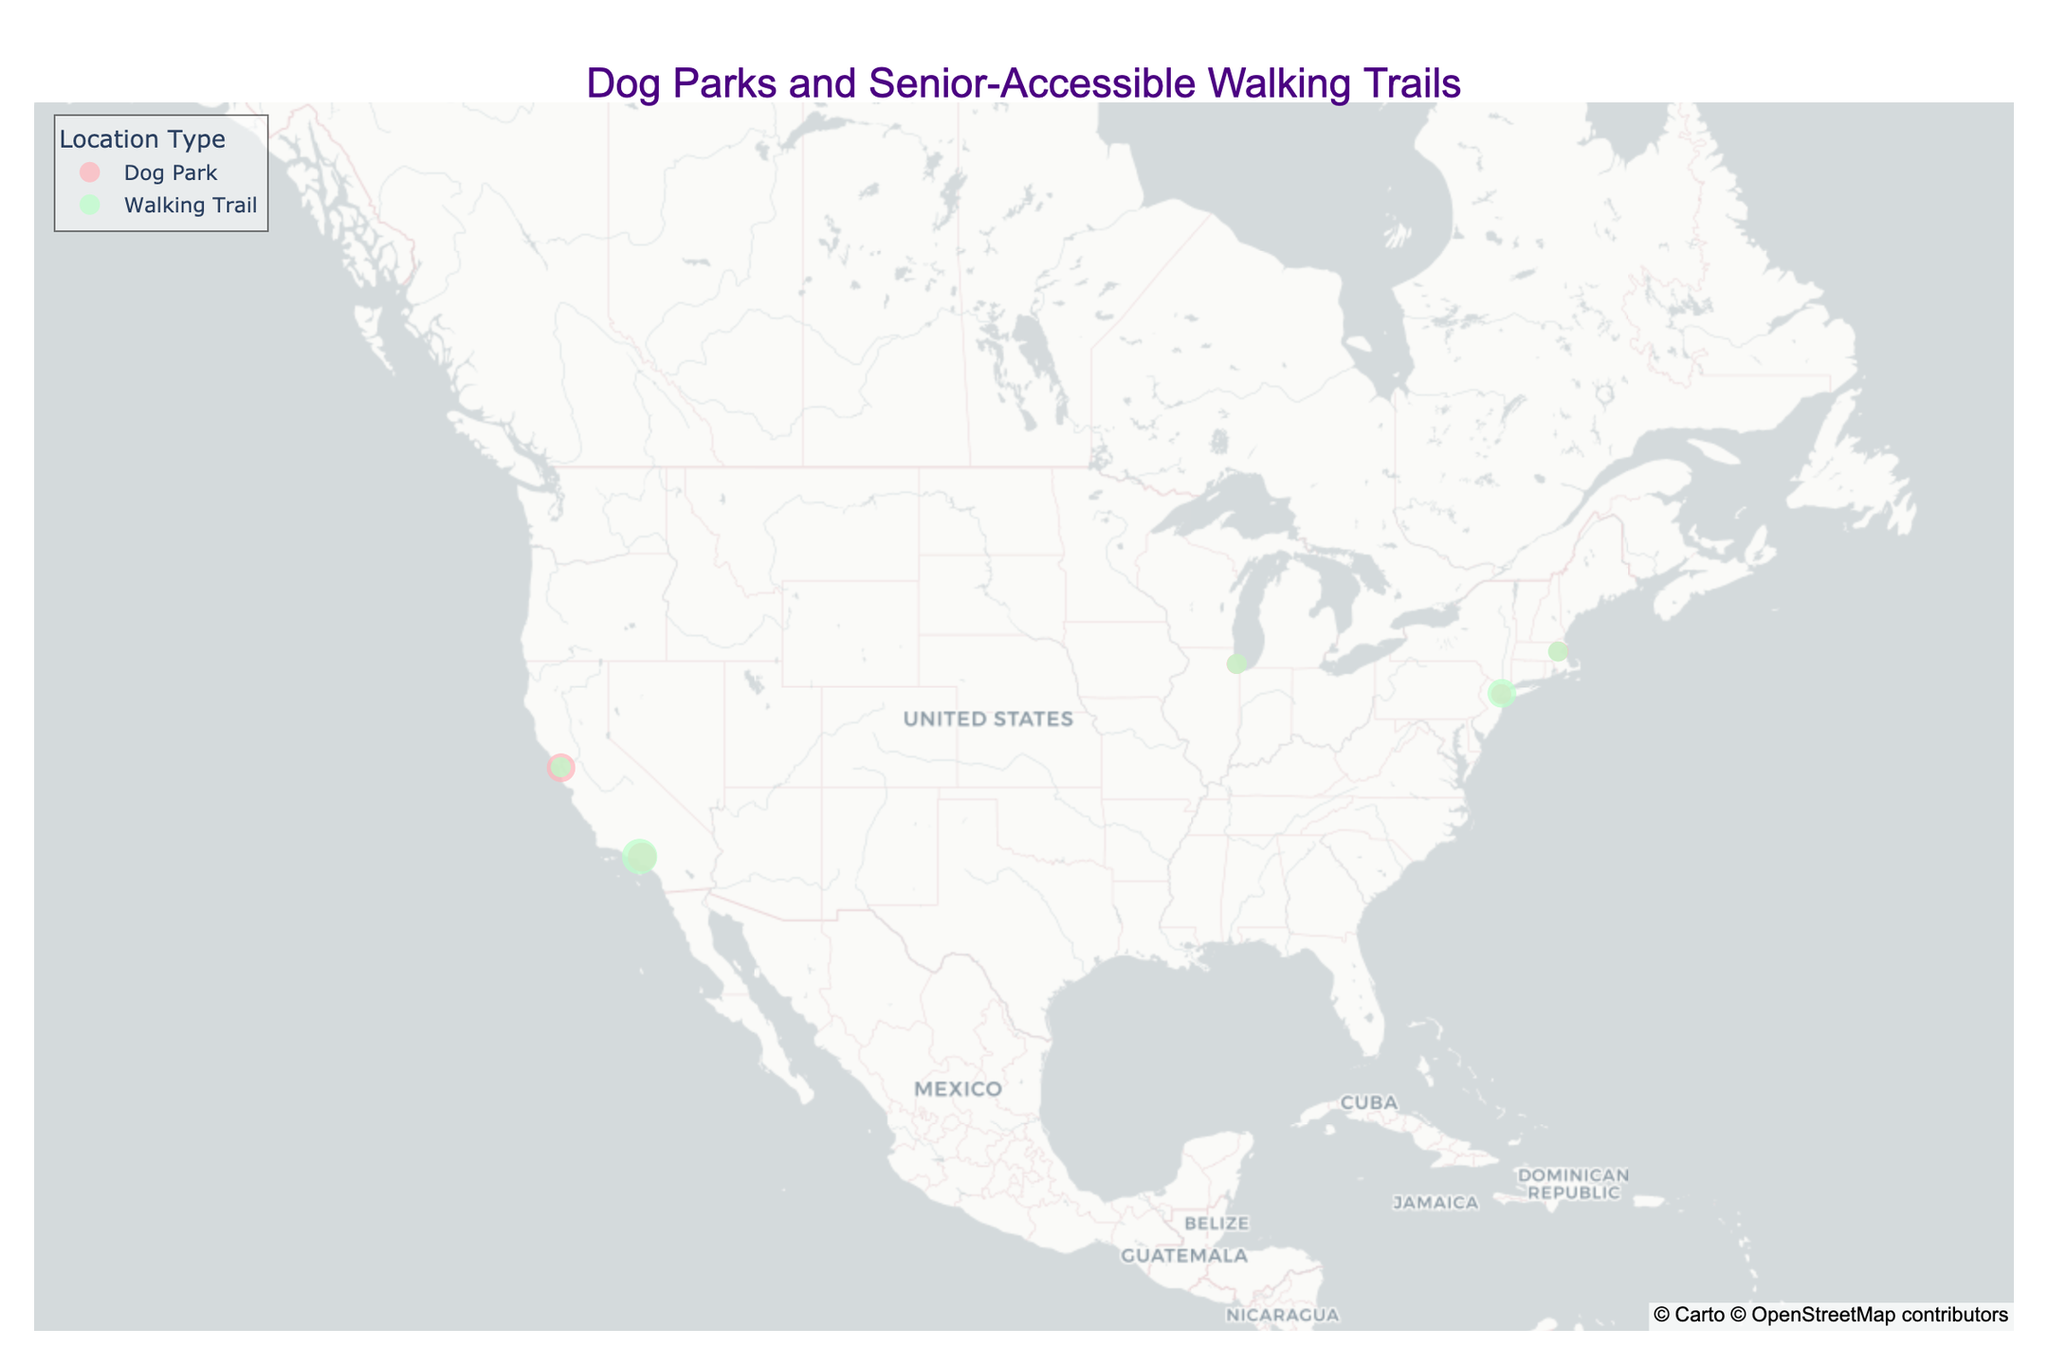What's the title of the map? The title is displayed at the top of the map in large letters. The title helps in understanding the main subject of the map.
Answer: Dog Parks and Senior-Accessible Walking Trails How many dog parks are marked on the map? To find the number of dog parks, look for data points that are colored according to the color assigned to dog parks. Each point represents one dog park.
Answer: 5 Which city has the highest number of senior-friendly walking trails? To determine this, count the number of walking trails that are marked as senior-friendly in each city.
Answer: New York What is the terrain difficulty level of Runyon Canyon Park? The terrain difficulty level is indicated by the size of the markers on the map. For Runyon Canyon Park, you can see the size to determine its rating.
Answer: 3 Which dog park is located in San Francisco? Look at the points in San Francisco and check the hover text or location name to find the dog park.
Answer: Fort Funston How does the terrain difficulty of Sepulveda Basin Off-Leash Dog Park compare to Montrose Dog Beach? Compare the marker sizes of both points on the map. Sepulveda Basin has a larger marker size indicating higher difficulty.
Answer: Sepulveda Basin is more difficult Which location type seems to have more senior-friendly options, dog parks or walking trails? Count the number of senior-friendly markers for each type (dog park or walking trail). Compare the total numbers.
Answer: Walking trails Are there any senior-friendly trails rated as terrain difficulty 3? Check the markers for senior-friendly trails and see if any have the largest size, which indicates terrain difficulty 3.
Answer: No Which city has a walking trail called "Charles River Esplanade"? Check the hover data or location names in each city to find "Charles River Esplanade".
Answer: Boston In which city can you find a dog park called "Central Park Dog Run"? Search for the specific dog park name in the hover data or location names displayed for each point in the cities.
Answer: New York 